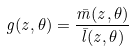<formula> <loc_0><loc_0><loc_500><loc_500>g ( z , \theta ) = \frac { \bar { m } ( z , \theta ) } { \bar { l } ( z , \theta ) }</formula> 